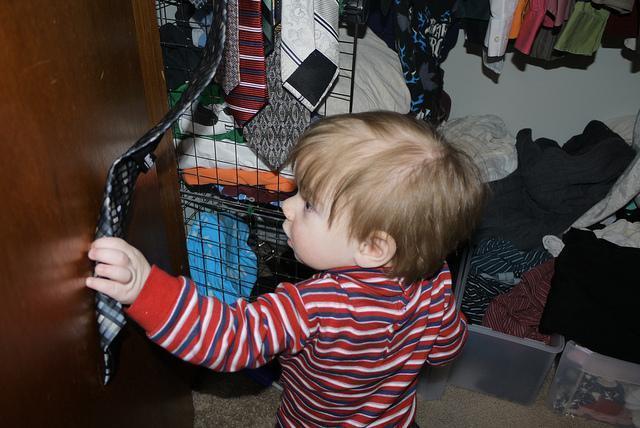How many ties are visible?
Give a very brief answer. 4. How many ducks have orange hats?
Give a very brief answer. 0. 